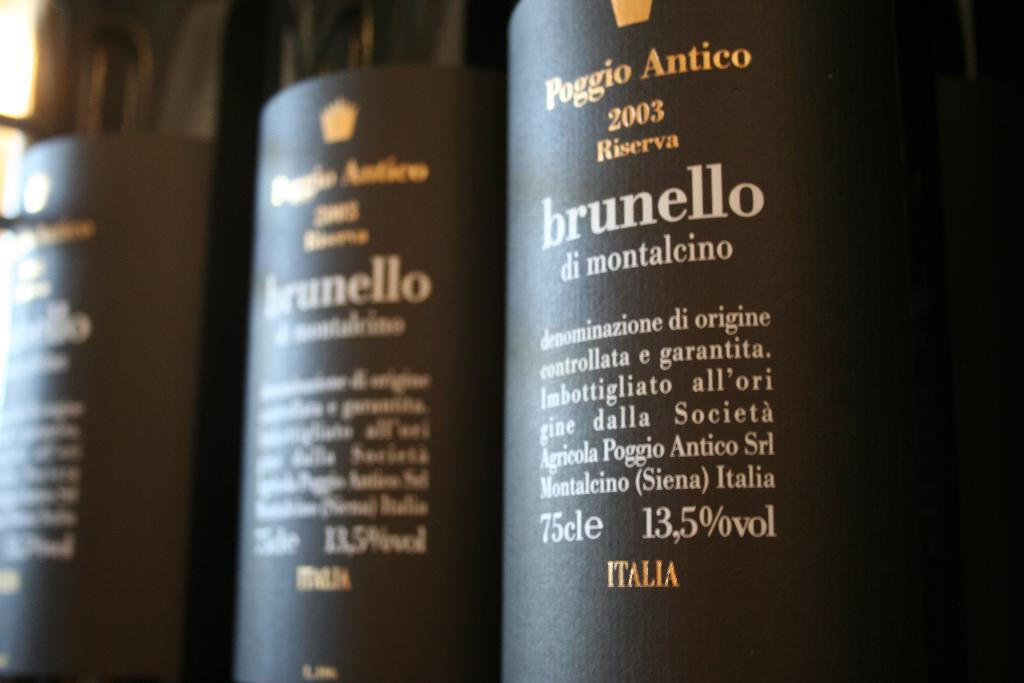<image>
Create a compact narrative representing the image presented. Three black bottles of Brunello right next to one another. 